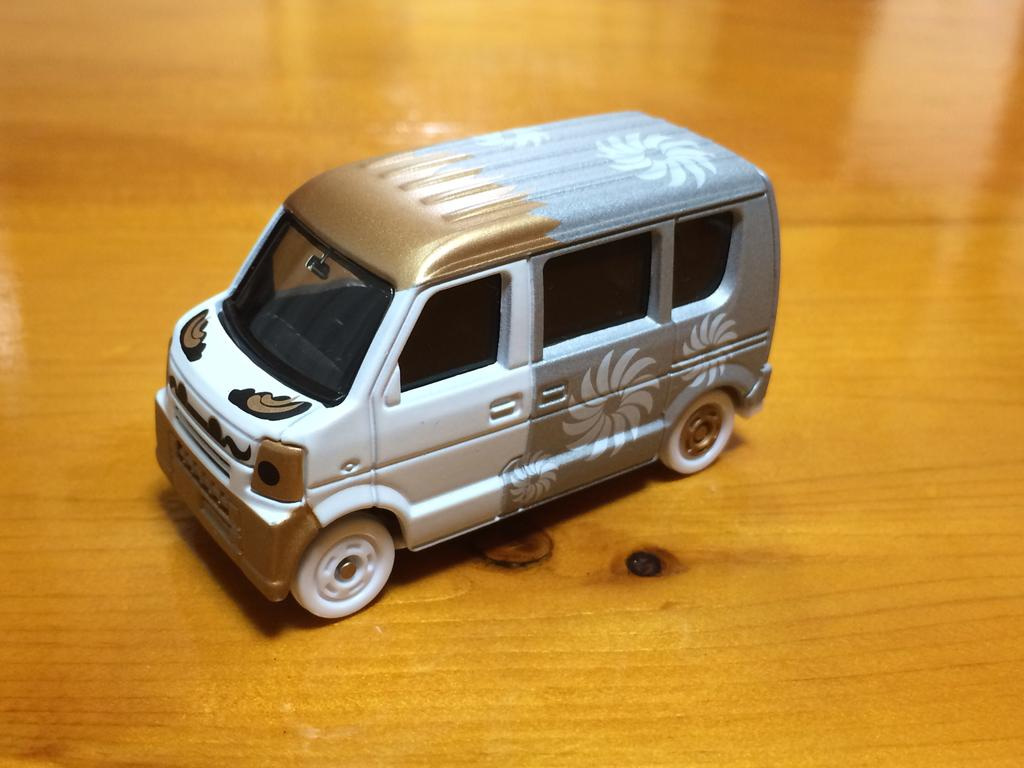What is the main object in the image? There is a toy car in the image. What type of surface is the toy car placed on? The toy car is on a wooden surface. Are there any cobwebs visible on the toy car in the image? There is no mention of cobwebs in the provided facts, and therefore we cannot determine if any are present in the image. 